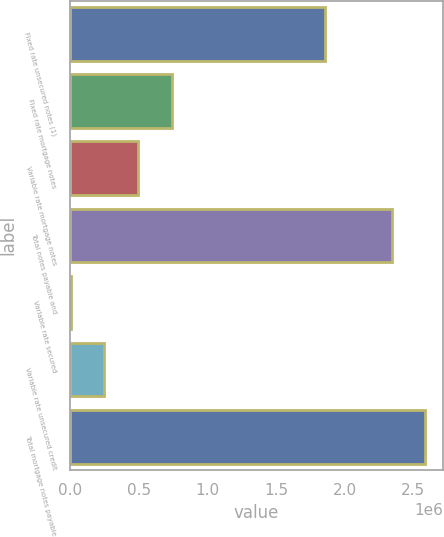<chart> <loc_0><loc_0><loc_500><loc_500><bar_chart><fcel>Fixed rate unsecured notes (1)<fcel>Fixed rate mortgage notes<fcel>Variable rate mortgage notes<fcel>Total notes payable and<fcel>Variable rate secured<fcel>Variable rate unsecured credit<fcel>Total mortgage notes payable<nl><fcel>1.85945e+06<fcel>739801<fcel>495293<fcel>2.34308e+06<fcel>6278<fcel>250786<fcel>2.58758e+06<nl></chart> 